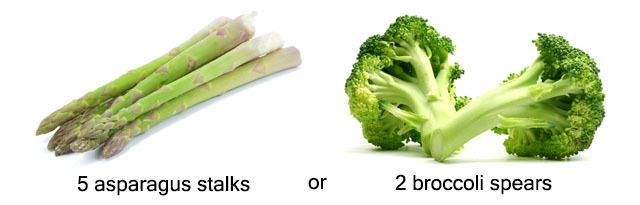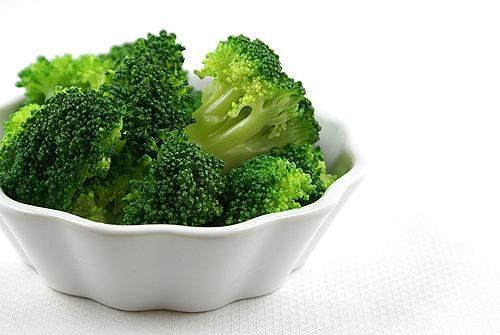The first image is the image on the left, the second image is the image on the right. For the images shown, is this caption "All of the images only feature broccoli pieces and nothing else." true? Answer yes or no. No. The first image is the image on the left, the second image is the image on the right. Given the left and right images, does the statement "One image shows broccoli florets that are on some type of roundish item." hold true? Answer yes or no. Yes. 